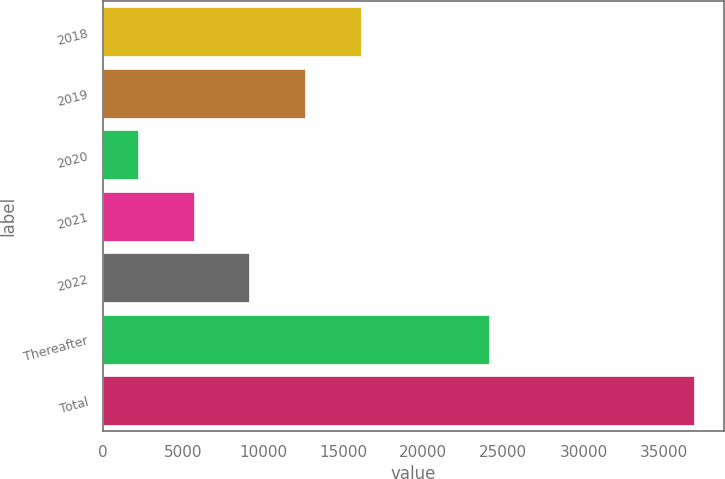Convert chart. <chart><loc_0><loc_0><loc_500><loc_500><bar_chart><fcel>2018<fcel>2019<fcel>2020<fcel>2021<fcel>2022<fcel>Thereafter<fcel>Total<nl><fcel>16088.8<fcel>12617.6<fcel>2204<fcel>5675.2<fcel>9146.4<fcel>24084<fcel>36916<nl></chart> 